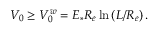Convert formula to latex. <formula><loc_0><loc_0><loc_500><loc_500>V _ { 0 } \geq V _ { 0 } ^ { w } = E _ { \ast } R _ { e } \ln \left ( L / R _ { e } \right ) .</formula> 